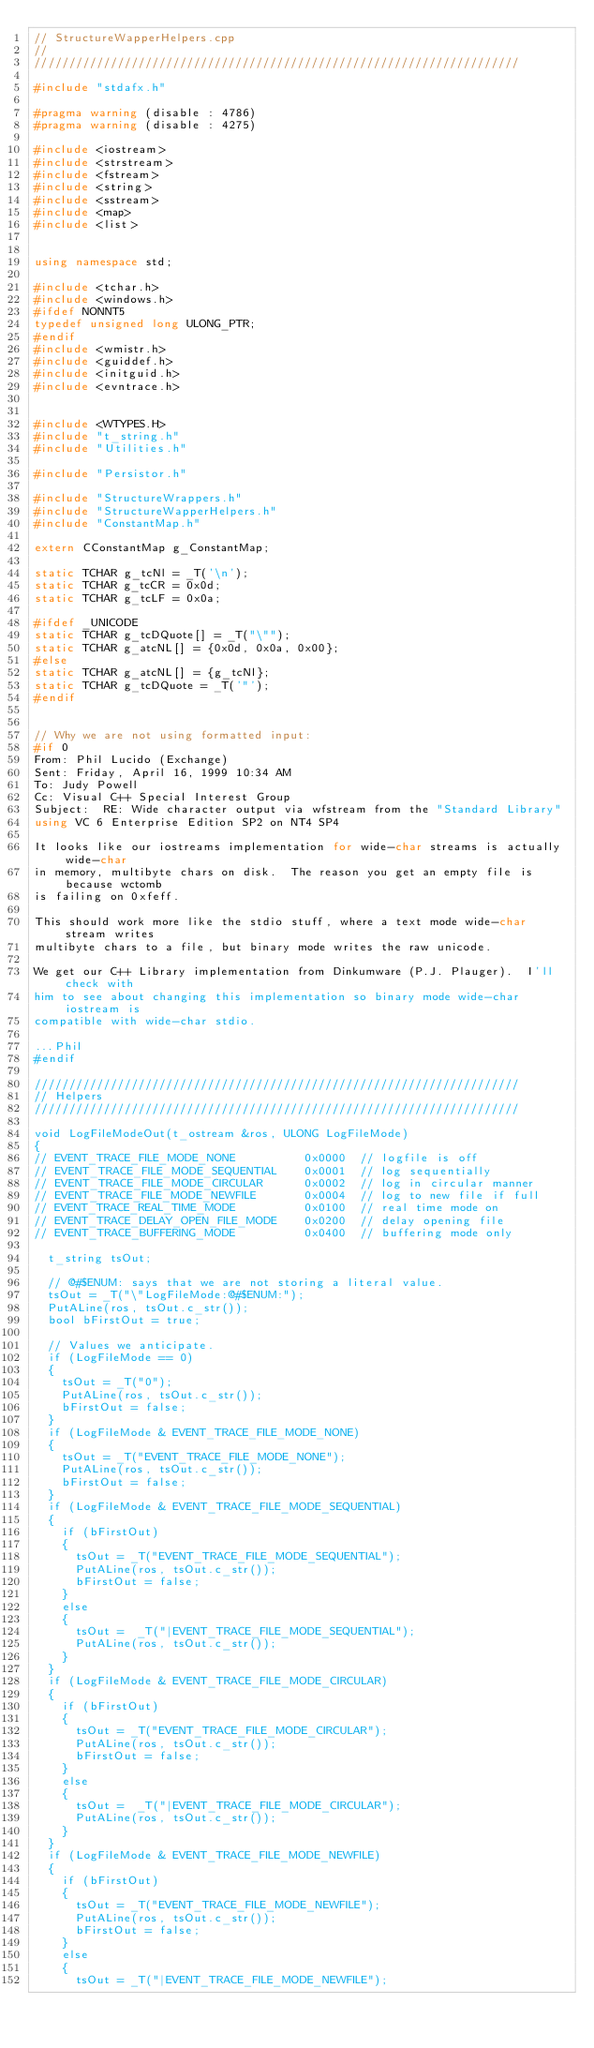<code> <loc_0><loc_0><loc_500><loc_500><_C++_>// StructureWapperHelpers.cpp
//
//////////////////////////////////////////////////////////////////////

#include "stdafx.h"

#pragma warning (disable : 4786)
#pragma warning (disable : 4275)

#include <iostream>
#include <strstream>
#include <fstream>
#include <string>
#include <sstream>
#include <map>
#include <list>


using namespace std;

#include <tchar.h>
#include <windows.h>
#ifdef NONNT5
typedef unsigned long ULONG_PTR;
#endif
#include <wmistr.h>
#include <guiddef.h>
#include <initguid.h>
#include <evntrace.h>


#include <WTYPES.H>
#include "t_string.h"
#include "Utilities.h"

#include "Persistor.h"

#include "StructureWrappers.h"
#include "StructureWapperHelpers.h"
#include "ConstantMap.h"
  
extern CConstantMap g_ConstantMap;

static TCHAR g_tcNl = _T('\n');
static TCHAR g_tcCR = 0x0d;
static TCHAR g_tcLF = 0x0a;

#ifdef _UNICODE
static TCHAR g_tcDQuote[] = _T("\"");
static TCHAR g_atcNL[] = {0x0d, 0x0a, 0x00};
#else
static TCHAR g_atcNL[] = {g_tcNl};
static TCHAR g_tcDQuote = _T('"');
#endif


// Why we are not using formatted input:
#if 0
From:	Phil Lucido (Exchange) 
Sent:	Friday, April 16, 1999 10:34 AM
To:	Judy Powell
Cc:	Visual C++ Special Interest Group
Subject:	RE: Wide character output via wfstream from the "Standard Library" 
using VC 6 Enterprise Edition SP2 on NT4 SP4

It looks like our iostreams implementation for wide-char streams is actually wide-char 
in memory, multibyte chars on disk.  The reason you get an empty file is because wctomb 
is failing on 0xfeff.

This should work more like the stdio stuff, where a text mode wide-char stream writes 
multibyte chars to a file, but binary mode writes the raw unicode.

We get our C++ Library implementation from Dinkumware (P.J. Plauger).  I'll check with 
him to see about changing this implementation so binary mode wide-char iostream is 
compatible with wide-char stdio.

...Phil
#endif

//////////////////////////////////////////////////////////////////////
// Helpers
//////////////////////////////////////////////////////////////////////

void LogFileModeOut(t_ostream &ros, ULONG LogFileMode)
{
// EVENT_TRACE_FILE_MODE_NONE          0x0000  // logfile is off
// EVENT_TRACE_FILE_MODE_SEQUENTIAL    0x0001  // log sequentially
// EVENT_TRACE_FILE_MODE_CIRCULAR      0x0002  // log in circular manner
// EVENT_TRACE_FILE_MODE_NEWFILE       0x0004  // log to new file if full
// EVENT_TRACE_REAL_TIME_MODE          0x0100  // real time mode on
// EVENT_TRACE_DELAY_OPEN_FILE_MODE    0x0200  // delay opening file
// EVENT_TRACE_BUFFERING_MODE          0x0400  // buffering mode only

	t_string tsOut;
	
	// @#$ENUM: says that we are not storing a literal value. 
	tsOut = _T("\"LogFileMode:@#$ENUM:");
	PutALine(ros, tsOut.c_str());
	bool bFirstOut = true;

	// Values we anticipate.
	if (LogFileMode == 0)
	{
		tsOut = _T("0");
		PutALine(ros, tsOut.c_str());
		bFirstOut = false;
	}
	if (LogFileMode & EVENT_TRACE_FILE_MODE_NONE)
	{
		tsOut = _T("EVENT_TRACE_FILE_MODE_NONE");
		PutALine(ros, tsOut.c_str());
		bFirstOut = false;
	}
	if (LogFileMode & EVENT_TRACE_FILE_MODE_SEQUENTIAL)
	{
		if (bFirstOut)
		{
			tsOut = _T("EVENT_TRACE_FILE_MODE_SEQUENTIAL");
			PutALine(ros, tsOut.c_str());
			bFirstOut = false;
		}
		else
		{
			tsOut =  _T("|EVENT_TRACE_FILE_MODE_SEQUENTIAL");
			PutALine(ros, tsOut.c_str());
		}
	}
	if (LogFileMode & EVENT_TRACE_FILE_MODE_CIRCULAR)
	{
		if (bFirstOut)
		{
			tsOut = _T("EVENT_TRACE_FILE_MODE_CIRCULAR");
			PutALine(ros, tsOut.c_str());
			bFirstOut = false;
		}
		else
		{
			tsOut =  _T("|EVENT_TRACE_FILE_MODE_CIRCULAR");
			PutALine(ros, tsOut.c_str());
		}
	}
	if (LogFileMode & EVENT_TRACE_FILE_MODE_NEWFILE)
	{
		if (bFirstOut)
		{
			tsOut = _T("EVENT_TRACE_FILE_MODE_NEWFILE");
			PutALine(ros, tsOut.c_str());
			bFirstOut = false;
		}
		else
		{
			tsOut = _T("|EVENT_TRACE_FILE_MODE_NEWFILE");</code> 